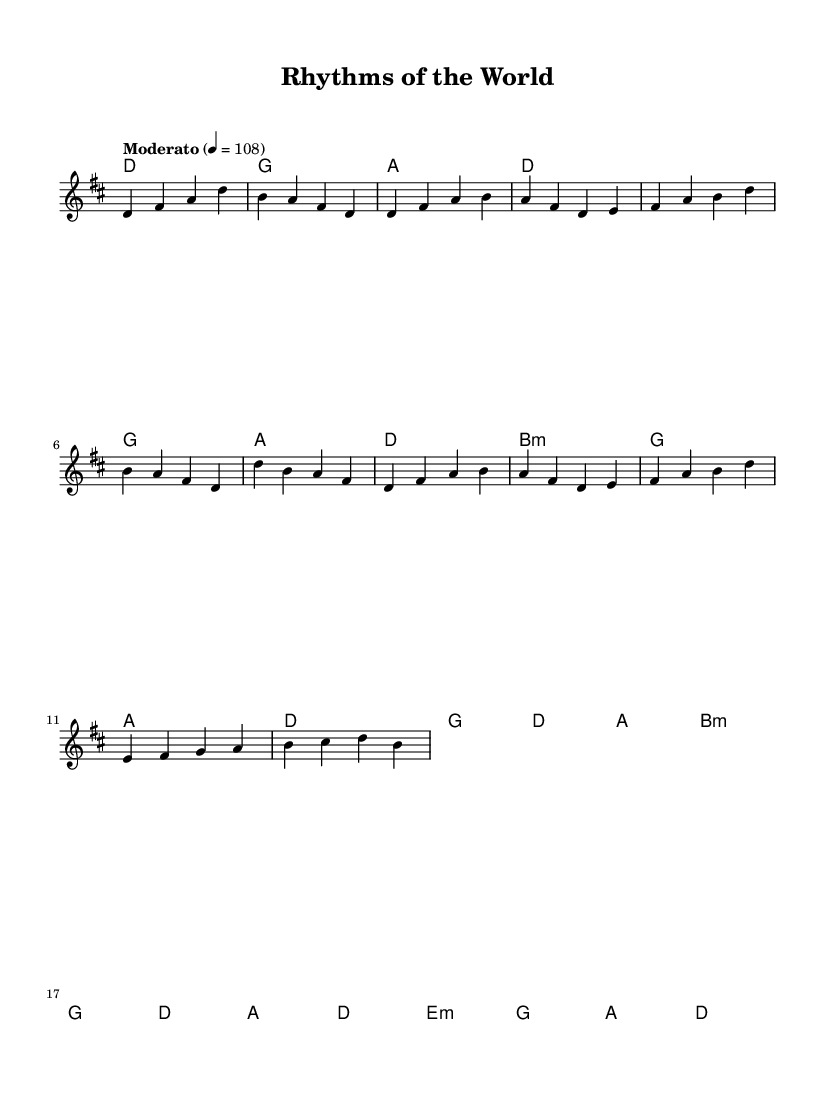What is the key signature of this music? The key signature is D major, indicated by two sharps in the key signature area of the sheet music.
Answer: D major What is the time signature of this music? The time signature shown in the sheet music is 4/4, which is represented at the beginning of the music, indicating four beats per measure.
Answer: 4/4 What is the tempo marking of this piece? The tempo marking is "Moderato," which indicates a moderate pace and appears at the start of the piece.
Answer: Moderato How many measures are in the verse section? The verse consists of two measures, which can be identified by the sequence of notes under the verse indication in the melody.
Answer: 4 measures Which chord is played in the second measure of the chorus? The chord played in the second measure of the chorus is D major, observable in the chord mode notation corresponding to the melody section.
Answer: D What is the first note of the bridge? The first note of the bridge is E, found at the beginning of the bridge section in the melody line.
Answer: E How many times does the 'A' note appear in the melody? The 'A' note appears four times in the melody, and can be counted directly from the melody line.
Answer: 4 